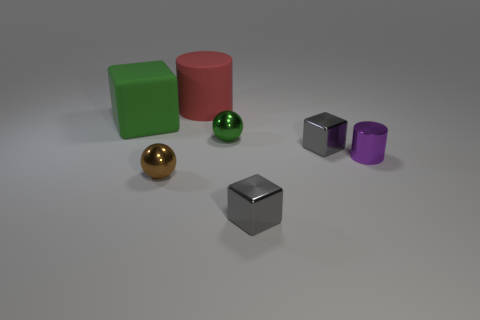What is the shape of the green thing that is the same material as the purple cylinder?
Give a very brief answer. Sphere. Are there more spheres behind the tiny shiny cylinder than small gray shiny blocks that are left of the big rubber block?
Provide a short and direct response. Yes. What number of objects are cubes or metal balls?
Offer a very short reply. 5. What number of other objects are the same color as the shiny cylinder?
Ensure brevity in your answer.  0. There is a purple metal thing that is the same size as the green ball; what shape is it?
Provide a short and direct response. Cylinder. What color is the rubber object that is left of the large cylinder?
Your response must be concise. Green. How many things are either rubber objects that are right of the green matte block or tiny metallic things that are to the left of the purple metallic cylinder?
Provide a succinct answer. 5. Is the size of the green block the same as the shiny cylinder?
Provide a short and direct response. No. How many spheres are large yellow things or large red objects?
Provide a succinct answer. 0. What number of things are in front of the rubber cube and behind the tiny purple cylinder?
Make the answer very short. 2. 